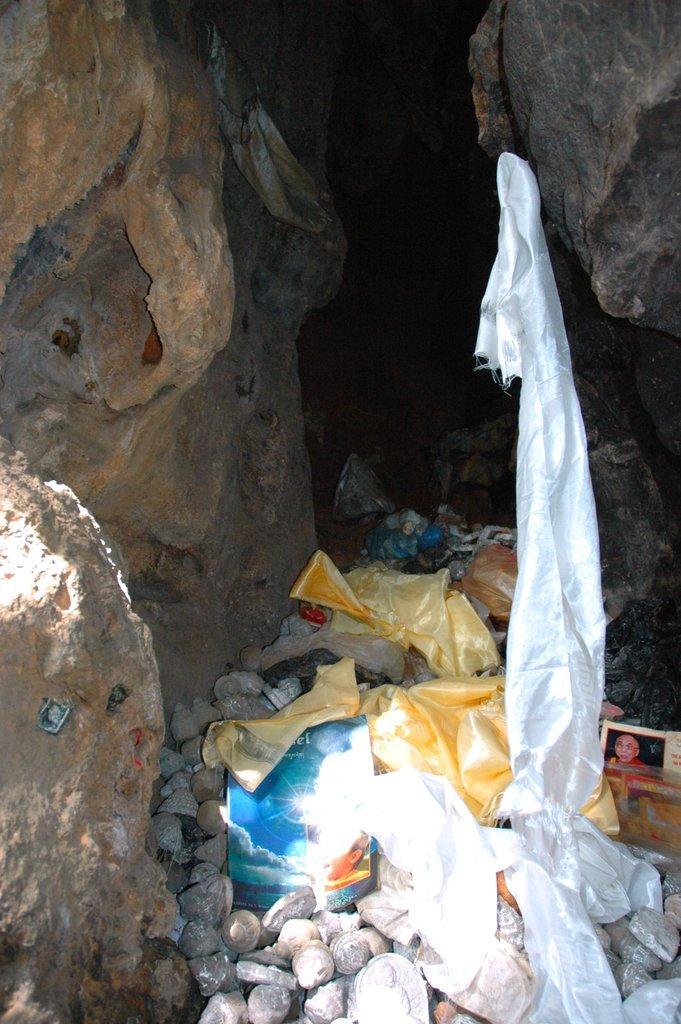Can you describe this image briefly? In this picture there are rocks on the right and left side of the image and there are pebbles, clothes, and books in the center of the image. 